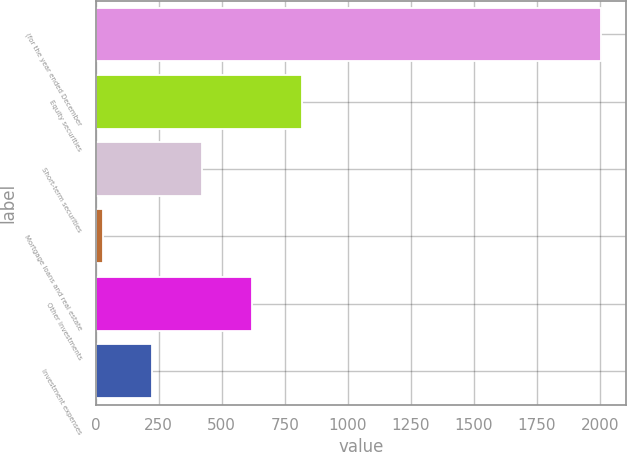Convert chart to OTSL. <chart><loc_0><loc_0><loc_500><loc_500><bar_chart><fcel>(for the year ended December<fcel>Equity securities<fcel>Short-term securities<fcel>Mortgage loans and real estate<fcel>Other investments<fcel>Investment expenses<nl><fcel>2003<fcel>818<fcel>423<fcel>28<fcel>620.5<fcel>225.5<nl></chart> 